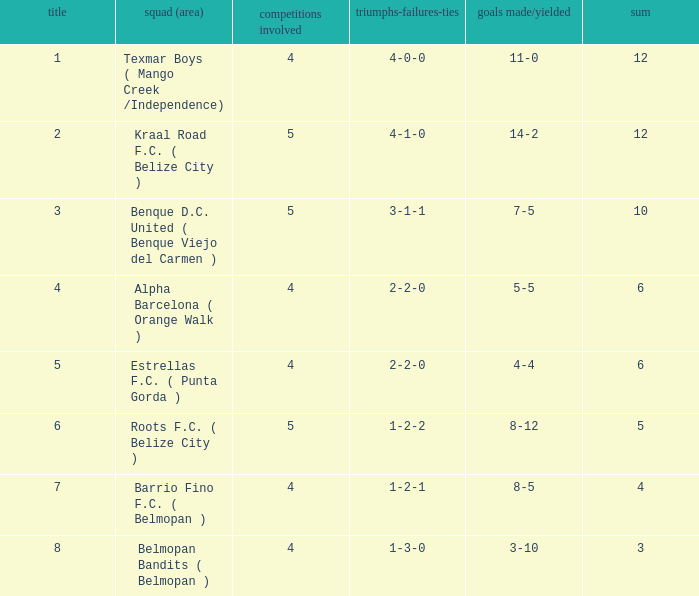What's the goals for/against with w-l-d being 3-1-1 7-5. 